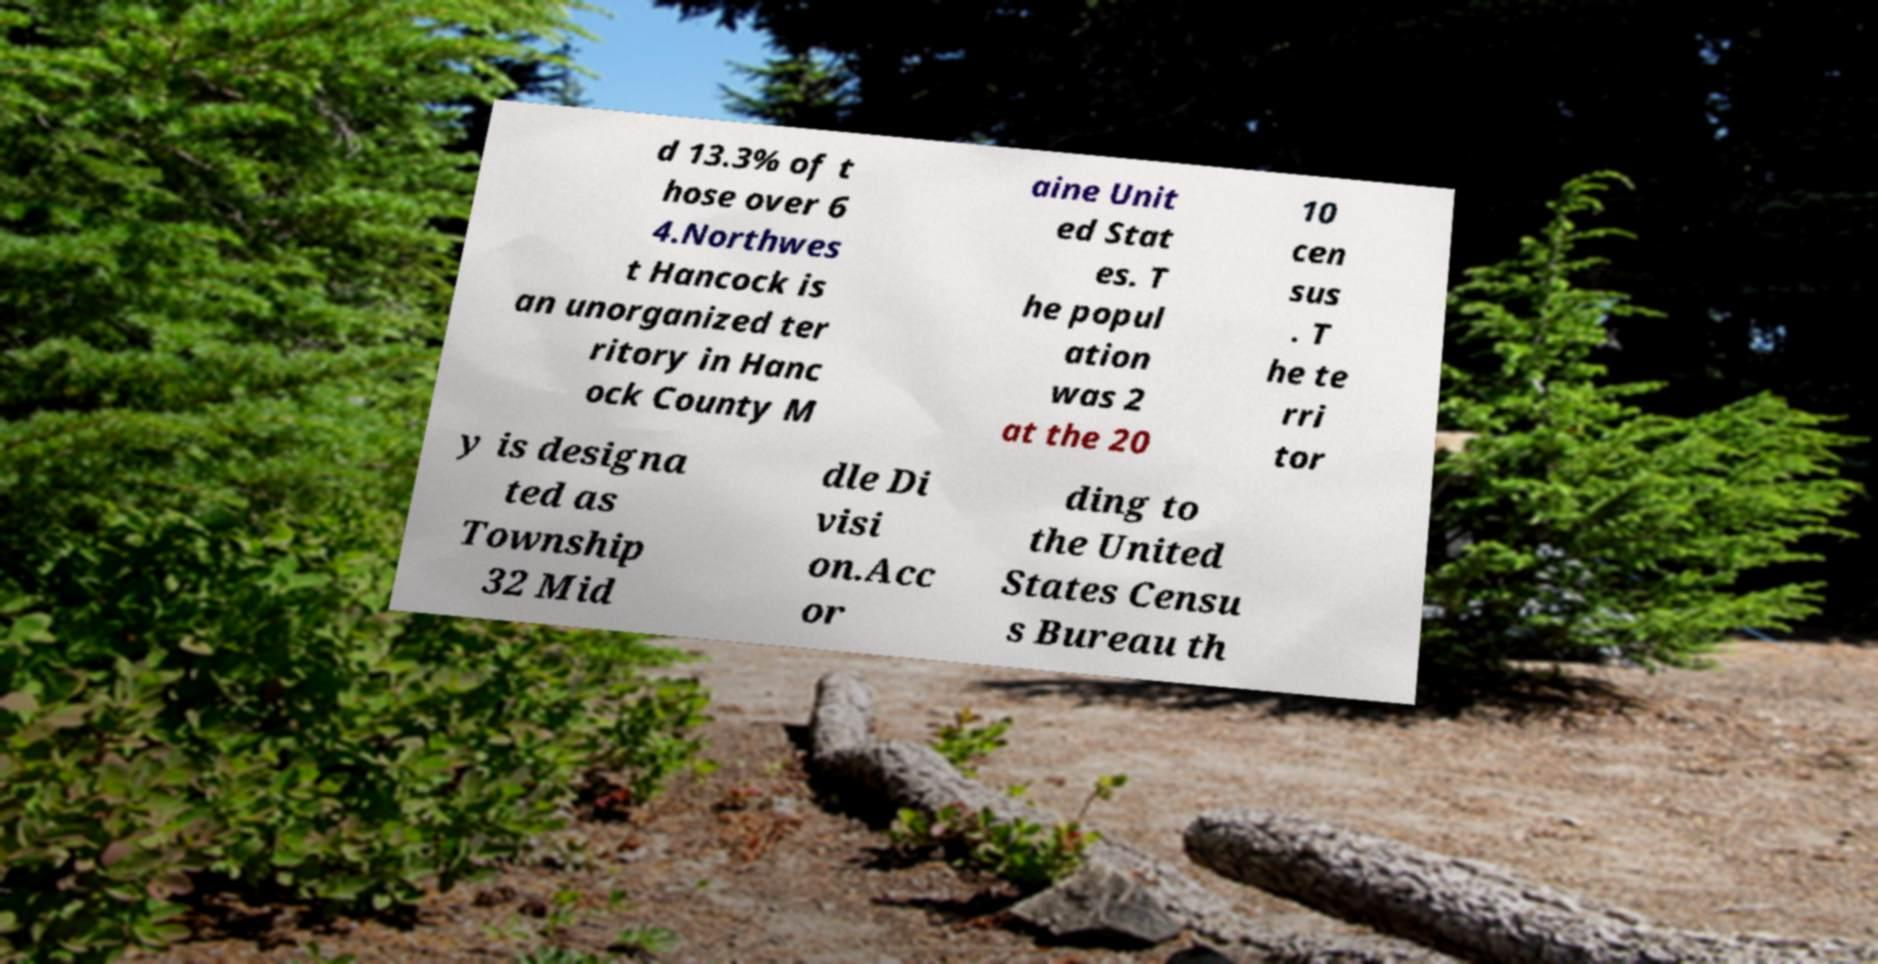Could you extract and type out the text from this image? d 13.3% of t hose over 6 4.Northwes t Hancock is an unorganized ter ritory in Hanc ock County M aine Unit ed Stat es. T he popul ation was 2 at the 20 10 cen sus . T he te rri tor y is designa ted as Township 32 Mid dle Di visi on.Acc or ding to the United States Censu s Bureau th 